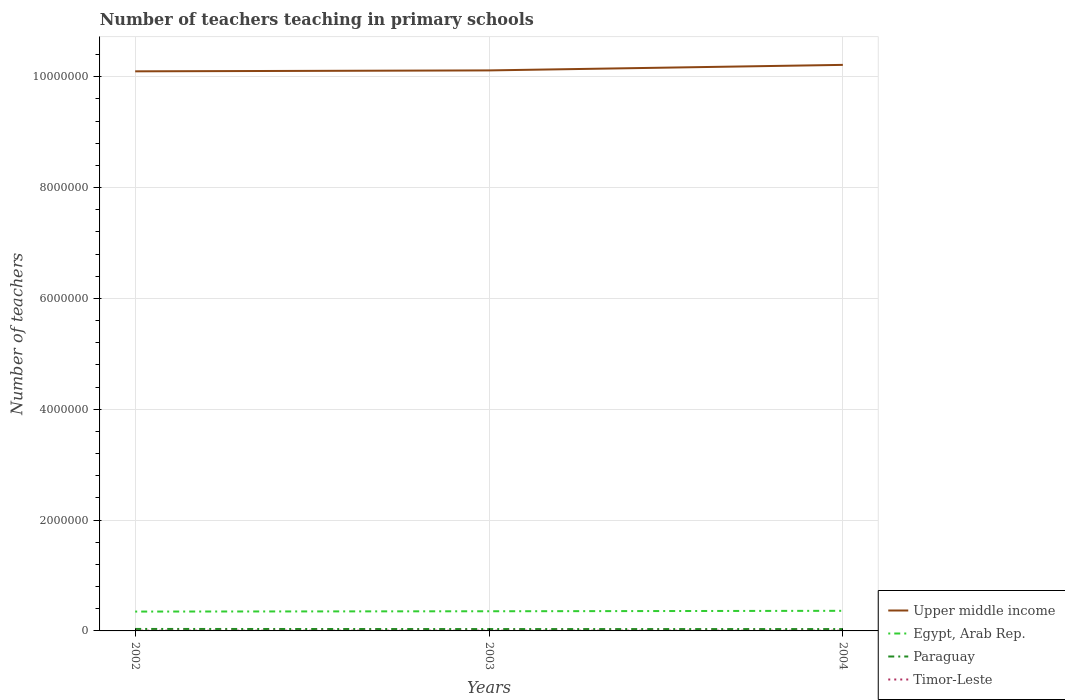How many different coloured lines are there?
Keep it short and to the point. 4. Does the line corresponding to Egypt, Arab Rep. intersect with the line corresponding to Paraguay?
Your answer should be compact. No. Is the number of lines equal to the number of legend labels?
Keep it short and to the point. Yes. Across all years, what is the maximum number of teachers teaching in primary schools in Egypt, Arab Rep.?
Make the answer very short. 3.49e+05. What is the total number of teachers teaching in primary schools in Timor-Leste in the graph?
Provide a short and direct response. 283. What is the difference between the highest and the second highest number of teachers teaching in primary schools in Egypt, Arab Rep.?
Offer a terse response. 1.35e+04. How many lines are there?
Your response must be concise. 4. How many years are there in the graph?
Make the answer very short. 3. Does the graph contain grids?
Keep it short and to the point. Yes. How are the legend labels stacked?
Provide a succinct answer. Vertical. What is the title of the graph?
Provide a short and direct response. Number of teachers teaching in primary schools. Does "Germany" appear as one of the legend labels in the graph?
Keep it short and to the point. No. What is the label or title of the Y-axis?
Offer a terse response. Number of teachers. What is the Number of teachers of Upper middle income in 2002?
Provide a short and direct response. 1.01e+07. What is the Number of teachers of Egypt, Arab Rep. in 2002?
Provide a short and direct response. 3.49e+05. What is the Number of teachers in Paraguay in 2002?
Ensure brevity in your answer.  3.57e+04. What is the Number of teachers of Timor-Leste in 2002?
Your response must be concise. 3901. What is the Number of teachers of Upper middle income in 2003?
Keep it short and to the point. 1.01e+07. What is the Number of teachers of Egypt, Arab Rep. in 2003?
Offer a very short reply. 3.55e+05. What is the Number of teachers of Paraguay in 2003?
Provide a short and direct response. 3.36e+04. What is the Number of teachers in Timor-Leste in 2003?
Keep it short and to the point. 3926. What is the Number of teachers of Upper middle income in 2004?
Your answer should be compact. 1.02e+07. What is the Number of teachers in Egypt, Arab Rep. in 2004?
Make the answer very short. 3.63e+05. What is the Number of teachers in Paraguay in 2004?
Keep it short and to the point. 3.34e+04. What is the Number of teachers in Timor-Leste in 2004?
Provide a short and direct response. 3618. Across all years, what is the maximum Number of teachers of Upper middle income?
Provide a short and direct response. 1.02e+07. Across all years, what is the maximum Number of teachers in Egypt, Arab Rep.?
Offer a very short reply. 3.63e+05. Across all years, what is the maximum Number of teachers of Paraguay?
Your response must be concise. 3.57e+04. Across all years, what is the maximum Number of teachers of Timor-Leste?
Make the answer very short. 3926. Across all years, what is the minimum Number of teachers of Upper middle income?
Keep it short and to the point. 1.01e+07. Across all years, what is the minimum Number of teachers in Egypt, Arab Rep.?
Give a very brief answer. 3.49e+05. Across all years, what is the minimum Number of teachers in Paraguay?
Ensure brevity in your answer.  3.34e+04. Across all years, what is the minimum Number of teachers in Timor-Leste?
Offer a very short reply. 3618. What is the total Number of teachers of Upper middle income in the graph?
Your answer should be compact. 3.04e+07. What is the total Number of teachers in Egypt, Arab Rep. in the graph?
Your answer should be compact. 1.07e+06. What is the total Number of teachers of Paraguay in the graph?
Your answer should be compact. 1.03e+05. What is the total Number of teachers of Timor-Leste in the graph?
Your answer should be very brief. 1.14e+04. What is the difference between the Number of teachers in Upper middle income in 2002 and that in 2003?
Offer a very short reply. -1.64e+04. What is the difference between the Number of teachers in Egypt, Arab Rep. in 2002 and that in 2003?
Keep it short and to the point. -5720. What is the difference between the Number of teachers in Paraguay in 2002 and that in 2003?
Provide a succinct answer. 2102. What is the difference between the Number of teachers in Timor-Leste in 2002 and that in 2003?
Ensure brevity in your answer.  -25. What is the difference between the Number of teachers of Upper middle income in 2002 and that in 2004?
Provide a succinct answer. -1.16e+05. What is the difference between the Number of teachers of Egypt, Arab Rep. in 2002 and that in 2004?
Give a very brief answer. -1.35e+04. What is the difference between the Number of teachers in Paraguay in 2002 and that in 2004?
Give a very brief answer. 2275. What is the difference between the Number of teachers in Timor-Leste in 2002 and that in 2004?
Your answer should be very brief. 283. What is the difference between the Number of teachers of Upper middle income in 2003 and that in 2004?
Offer a terse response. -1.00e+05. What is the difference between the Number of teachers of Egypt, Arab Rep. in 2003 and that in 2004?
Your answer should be compact. -7777. What is the difference between the Number of teachers in Paraguay in 2003 and that in 2004?
Offer a very short reply. 173. What is the difference between the Number of teachers in Timor-Leste in 2003 and that in 2004?
Your answer should be compact. 308. What is the difference between the Number of teachers in Upper middle income in 2002 and the Number of teachers in Egypt, Arab Rep. in 2003?
Offer a very short reply. 9.74e+06. What is the difference between the Number of teachers in Upper middle income in 2002 and the Number of teachers in Paraguay in 2003?
Ensure brevity in your answer.  1.01e+07. What is the difference between the Number of teachers of Upper middle income in 2002 and the Number of teachers of Timor-Leste in 2003?
Make the answer very short. 1.01e+07. What is the difference between the Number of teachers in Egypt, Arab Rep. in 2002 and the Number of teachers in Paraguay in 2003?
Provide a short and direct response. 3.16e+05. What is the difference between the Number of teachers of Egypt, Arab Rep. in 2002 and the Number of teachers of Timor-Leste in 2003?
Give a very brief answer. 3.45e+05. What is the difference between the Number of teachers of Paraguay in 2002 and the Number of teachers of Timor-Leste in 2003?
Make the answer very short. 3.18e+04. What is the difference between the Number of teachers of Upper middle income in 2002 and the Number of teachers of Egypt, Arab Rep. in 2004?
Make the answer very short. 9.73e+06. What is the difference between the Number of teachers of Upper middle income in 2002 and the Number of teachers of Paraguay in 2004?
Your answer should be very brief. 1.01e+07. What is the difference between the Number of teachers of Upper middle income in 2002 and the Number of teachers of Timor-Leste in 2004?
Ensure brevity in your answer.  1.01e+07. What is the difference between the Number of teachers of Egypt, Arab Rep. in 2002 and the Number of teachers of Paraguay in 2004?
Keep it short and to the point. 3.16e+05. What is the difference between the Number of teachers of Egypt, Arab Rep. in 2002 and the Number of teachers of Timor-Leste in 2004?
Give a very brief answer. 3.46e+05. What is the difference between the Number of teachers in Paraguay in 2002 and the Number of teachers in Timor-Leste in 2004?
Offer a very short reply. 3.21e+04. What is the difference between the Number of teachers in Upper middle income in 2003 and the Number of teachers in Egypt, Arab Rep. in 2004?
Offer a terse response. 9.75e+06. What is the difference between the Number of teachers of Upper middle income in 2003 and the Number of teachers of Paraguay in 2004?
Your answer should be very brief. 1.01e+07. What is the difference between the Number of teachers in Upper middle income in 2003 and the Number of teachers in Timor-Leste in 2004?
Make the answer very short. 1.01e+07. What is the difference between the Number of teachers in Egypt, Arab Rep. in 2003 and the Number of teachers in Paraguay in 2004?
Keep it short and to the point. 3.21e+05. What is the difference between the Number of teachers in Egypt, Arab Rep. in 2003 and the Number of teachers in Timor-Leste in 2004?
Make the answer very short. 3.51e+05. What is the difference between the Number of teachers of Paraguay in 2003 and the Number of teachers of Timor-Leste in 2004?
Ensure brevity in your answer.  3.00e+04. What is the average Number of teachers of Upper middle income per year?
Your response must be concise. 1.01e+07. What is the average Number of teachers in Egypt, Arab Rep. per year?
Provide a succinct answer. 3.56e+05. What is the average Number of teachers in Paraguay per year?
Make the answer very short. 3.42e+04. What is the average Number of teachers of Timor-Leste per year?
Your answer should be very brief. 3815. In the year 2002, what is the difference between the Number of teachers in Upper middle income and Number of teachers in Egypt, Arab Rep.?
Offer a terse response. 9.75e+06. In the year 2002, what is the difference between the Number of teachers of Upper middle income and Number of teachers of Paraguay?
Keep it short and to the point. 1.01e+07. In the year 2002, what is the difference between the Number of teachers in Upper middle income and Number of teachers in Timor-Leste?
Offer a very short reply. 1.01e+07. In the year 2002, what is the difference between the Number of teachers in Egypt, Arab Rep. and Number of teachers in Paraguay?
Your answer should be very brief. 3.13e+05. In the year 2002, what is the difference between the Number of teachers of Egypt, Arab Rep. and Number of teachers of Timor-Leste?
Offer a very short reply. 3.45e+05. In the year 2002, what is the difference between the Number of teachers of Paraguay and Number of teachers of Timor-Leste?
Give a very brief answer. 3.18e+04. In the year 2003, what is the difference between the Number of teachers of Upper middle income and Number of teachers of Egypt, Arab Rep.?
Offer a terse response. 9.76e+06. In the year 2003, what is the difference between the Number of teachers of Upper middle income and Number of teachers of Paraguay?
Give a very brief answer. 1.01e+07. In the year 2003, what is the difference between the Number of teachers in Upper middle income and Number of teachers in Timor-Leste?
Give a very brief answer. 1.01e+07. In the year 2003, what is the difference between the Number of teachers of Egypt, Arab Rep. and Number of teachers of Paraguay?
Offer a very short reply. 3.21e+05. In the year 2003, what is the difference between the Number of teachers of Egypt, Arab Rep. and Number of teachers of Timor-Leste?
Your response must be concise. 3.51e+05. In the year 2003, what is the difference between the Number of teachers of Paraguay and Number of teachers of Timor-Leste?
Provide a short and direct response. 2.97e+04. In the year 2004, what is the difference between the Number of teachers of Upper middle income and Number of teachers of Egypt, Arab Rep.?
Provide a succinct answer. 9.85e+06. In the year 2004, what is the difference between the Number of teachers in Upper middle income and Number of teachers in Paraguay?
Ensure brevity in your answer.  1.02e+07. In the year 2004, what is the difference between the Number of teachers in Upper middle income and Number of teachers in Timor-Leste?
Make the answer very short. 1.02e+07. In the year 2004, what is the difference between the Number of teachers in Egypt, Arab Rep. and Number of teachers in Paraguay?
Give a very brief answer. 3.29e+05. In the year 2004, what is the difference between the Number of teachers in Egypt, Arab Rep. and Number of teachers in Timor-Leste?
Provide a short and direct response. 3.59e+05. In the year 2004, what is the difference between the Number of teachers of Paraguay and Number of teachers of Timor-Leste?
Make the answer very short. 2.98e+04. What is the ratio of the Number of teachers of Upper middle income in 2002 to that in 2003?
Provide a short and direct response. 1. What is the ratio of the Number of teachers of Egypt, Arab Rep. in 2002 to that in 2003?
Make the answer very short. 0.98. What is the ratio of the Number of teachers in Paraguay in 2002 to that in 2003?
Give a very brief answer. 1.06. What is the ratio of the Number of teachers of Timor-Leste in 2002 to that in 2003?
Keep it short and to the point. 0.99. What is the ratio of the Number of teachers in Upper middle income in 2002 to that in 2004?
Offer a terse response. 0.99. What is the ratio of the Number of teachers in Egypt, Arab Rep. in 2002 to that in 2004?
Make the answer very short. 0.96. What is the ratio of the Number of teachers in Paraguay in 2002 to that in 2004?
Your response must be concise. 1.07. What is the ratio of the Number of teachers in Timor-Leste in 2002 to that in 2004?
Provide a short and direct response. 1.08. What is the ratio of the Number of teachers in Upper middle income in 2003 to that in 2004?
Your response must be concise. 0.99. What is the ratio of the Number of teachers of Egypt, Arab Rep. in 2003 to that in 2004?
Keep it short and to the point. 0.98. What is the ratio of the Number of teachers of Timor-Leste in 2003 to that in 2004?
Your answer should be compact. 1.09. What is the difference between the highest and the second highest Number of teachers in Upper middle income?
Offer a terse response. 1.00e+05. What is the difference between the highest and the second highest Number of teachers of Egypt, Arab Rep.?
Make the answer very short. 7777. What is the difference between the highest and the second highest Number of teachers in Paraguay?
Your response must be concise. 2102. What is the difference between the highest and the lowest Number of teachers in Upper middle income?
Offer a terse response. 1.16e+05. What is the difference between the highest and the lowest Number of teachers of Egypt, Arab Rep.?
Offer a very short reply. 1.35e+04. What is the difference between the highest and the lowest Number of teachers of Paraguay?
Give a very brief answer. 2275. What is the difference between the highest and the lowest Number of teachers in Timor-Leste?
Give a very brief answer. 308. 